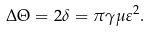<formula> <loc_0><loc_0><loc_500><loc_500>\Delta \Theta = 2 \delta = \pi \gamma \mu \varepsilon ^ { 2 } .</formula> 